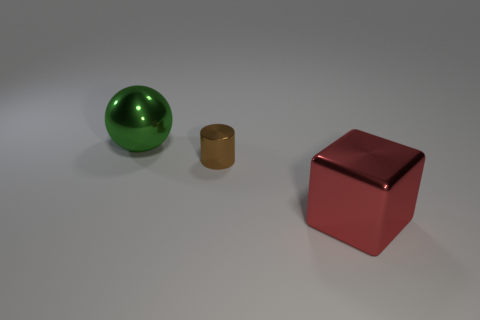Are there any cylinders of the same size as the red block?
Offer a very short reply. No. What is the color of the large block that is the same material as the large green thing?
Provide a short and direct response. Red. There is a big metal object left of the cylinder; how many brown cylinders are on the left side of it?
Give a very brief answer. 0. There is a metal thing that is on the left side of the small shiny thing; is it the same shape as the large red metal thing?
Provide a succinct answer. No. Are there fewer tiny cyan blocks than brown metal objects?
Provide a succinct answer. Yes. Is the number of red shiny objects greater than the number of brown metal cubes?
Give a very brief answer. Yes. Do the cube and the big object left of the small object have the same material?
Offer a terse response. Yes. What number of things are either yellow matte things or big red cubes?
Offer a very short reply. 1. How many cylinders are big red objects or yellow matte things?
Make the answer very short. 0. Are there any green matte blocks?
Provide a succinct answer. No. 